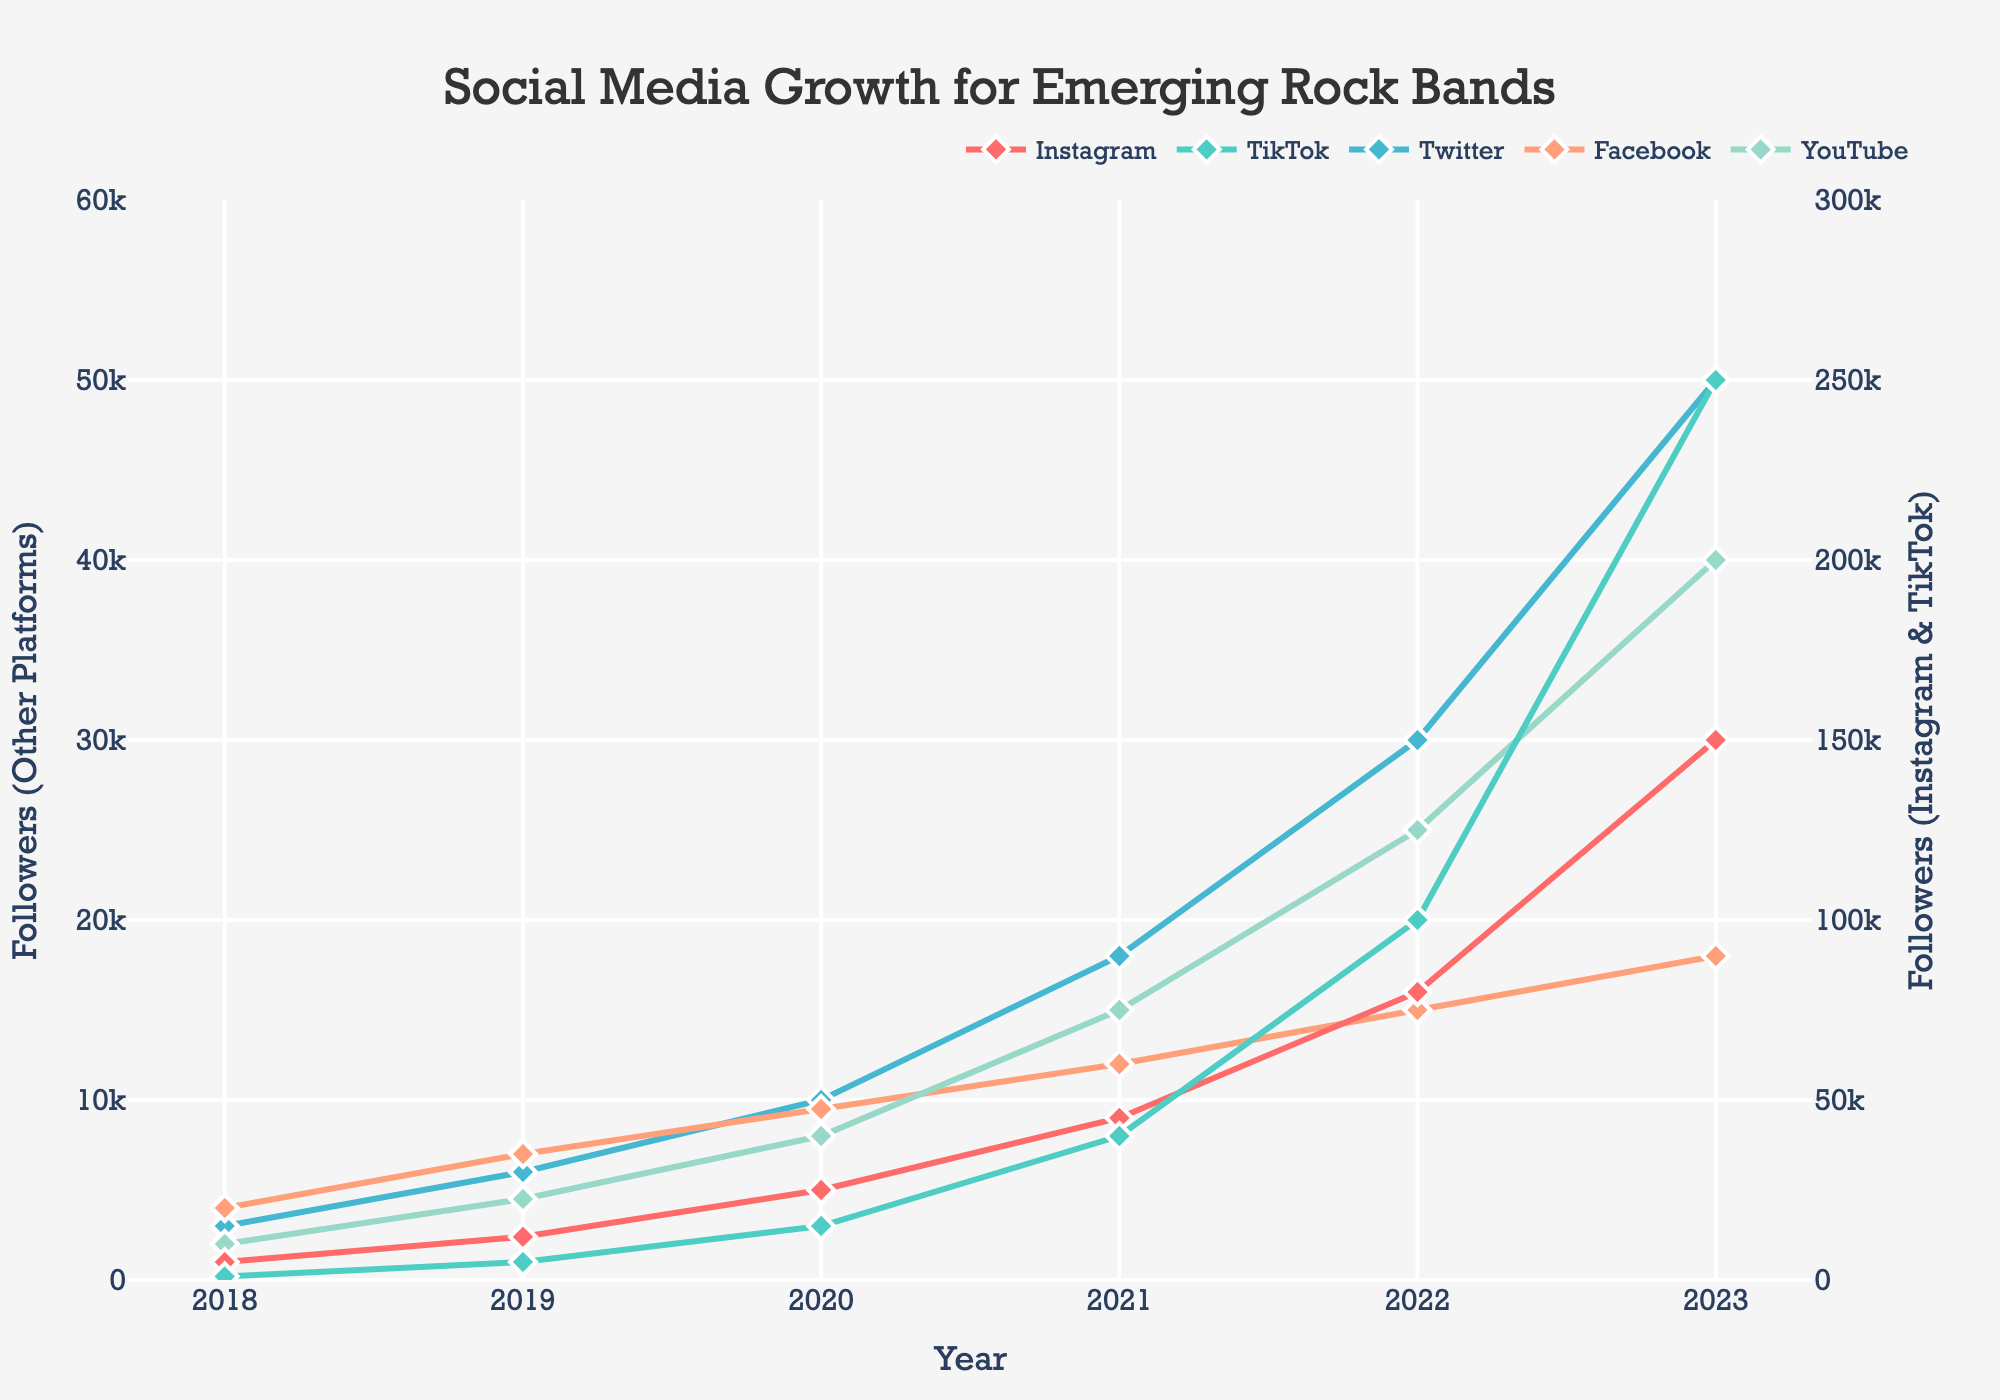What is the difference in TikTok followers between 2020 and 2022? In 2020, the number of TikTok followers is 15,000. In 2022, it is 100,000. The difference is 100,000 - 15,000 = 85,000
Answer: 85,000 Which platform had the highest follower growth from 2018 to 2023? To determine this, look at the increase in followers for each platform from 2018 to 2023. TikTok grew from 1,000 to 250,000; Instagram from 5,000 to 150,000; Twitter from 3,000 to 50,000; Facebook from 4,000 to 18,000; YouTube from 2,000 to 40,000. TikTok had the highest increase, which is 250,000 - 1,000 = 249,000
Answer: TikTok What year did Instagram surpass 50,000 followers? By observing the graph, Instagram reaches 50,000 followers in the year between 2021 and 2022, specifically, it crosses 50,000 in 2022
Answer: 2022 Compare the rate of growth in followers for Instagram and Twitter from 2021 to 2023. Which one grew faster? From 2021 to 2023, Instagram grew from 45,000 to 150,000 followers, an increase of 105,000. Twitter grew from 18,000 to 50,000 followers, an increase of 32,000. Since 105,000 is greater than 32,000, Instagram grew faster
Answer: Instagram How many total followers did YouTube have by the end of the 5-year period? By the end of the period in 2023, YouTube had 40,000 followers
Answer: 40,000 In which year did Facebook have the slowest growth in followers? To find this, compare the yearly increments of Facebook followers. From 2018 to 2019, the growth was 3,000; from 2019 to 2020, it was 2,500; from 2020 to 2021, it was 2,500; from 2021 to 2022, it was 3,000; from 2022 to 2023, it was 3,000. The slowest growth was from 2019 to 2021 (both periods with an increase of 2,500)
Answer: 2019-2020 Which platform reached 40,000 followers first? Observe the plot for the year each platform surpasses 40,000 followers. Instagram reaches this milestone in 2021, while all others do so later
Answer: Instagram What is the average number of Twitter followers over the 5-year period? Sum up the followers for Twitter for all years and divide by the number of years: (3,000 + 6,000 + 10,000 + 18,000 + 30,000 + 50,000)/6 = 19,166.67
Answer: 19,166.67 How many more followers did TikTok have than Facebook by 2023? By 2023, TikTok had 250,000 followers, and Facebook had 18,000. The difference is 250,000 - 18,000 = 232,000
Answer: 232,000 